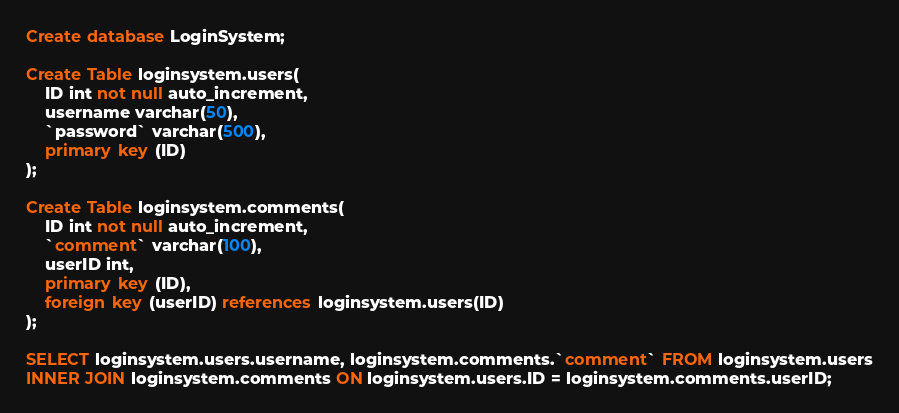<code> <loc_0><loc_0><loc_500><loc_500><_SQL_>Create database LoginSystem;

Create Table loginsystem.users(
	ID int not null auto_increment,
    username varchar(50),
    `password` varchar(500),
    primary key (ID)
);

Create Table loginsystem.comments(
	ID int not null auto_increment,
    `comment` varchar(100),
    userID int, 
    primary key (ID),
    foreign key (userID) references loginsystem.users(ID)
);

SELECT loginsystem.users.username, loginsystem.comments.`comment` FROM loginsystem.users
INNER JOIN loginsystem.comments ON loginsystem.users.ID = loginsystem.comments.userID;</code> 